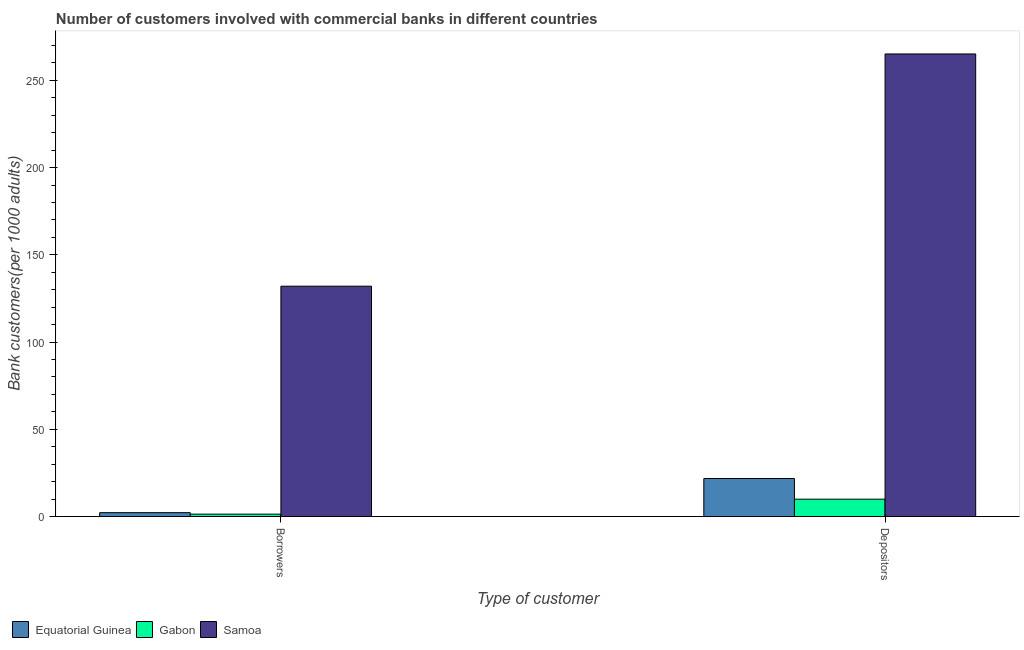How many different coloured bars are there?
Your answer should be very brief. 3. How many groups of bars are there?
Provide a short and direct response. 2. Are the number of bars per tick equal to the number of legend labels?
Your answer should be compact. Yes. Are the number of bars on each tick of the X-axis equal?
Your answer should be compact. Yes. How many bars are there on the 1st tick from the left?
Your answer should be compact. 3. What is the label of the 1st group of bars from the left?
Your answer should be compact. Borrowers. What is the number of borrowers in Samoa?
Give a very brief answer. 132.03. Across all countries, what is the maximum number of borrowers?
Offer a very short reply. 132.03. Across all countries, what is the minimum number of borrowers?
Make the answer very short. 1.38. In which country was the number of depositors maximum?
Ensure brevity in your answer.  Samoa. In which country was the number of depositors minimum?
Your answer should be very brief. Gabon. What is the total number of depositors in the graph?
Provide a short and direct response. 296.91. What is the difference between the number of depositors in Samoa and that in Equatorial Guinea?
Offer a terse response. 243.35. What is the difference between the number of borrowers in Equatorial Guinea and the number of depositors in Samoa?
Your response must be concise. -262.93. What is the average number of borrowers per country?
Provide a short and direct response. 45.21. What is the difference between the number of depositors and number of borrowers in Gabon?
Keep it short and to the point. 8.58. In how many countries, is the number of depositors greater than 40 ?
Provide a short and direct response. 1. What is the ratio of the number of borrowers in Samoa to that in Gabon?
Ensure brevity in your answer.  95.39. Is the number of borrowers in Equatorial Guinea less than that in Samoa?
Your response must be concise. Yes. What does the 1st bar from the left in Borrowers represents?
Make the answer very short. Equatorial Guinea. What does the 2nd bar from the right in Depositors represents?
Your response must be concise. Gabon. Where does the legend appear in the graph?
Keep it short and to the point. Bottom left. How are the legend labels stacked?
Provide a short and direct response. Horizontal. What is the title of the graph?
Your answer should be compact. Number of customers involved with commercial banks in different countries. What is the label or title of the X-axis?
Provide a short and direct response. Type of customer. What is the label or title of the Y-axis?
Offer a very short reply. Bank customers(per 1000 adults). What is the Bank customers(per 1000 adults) of Equatorial Guinea in Borrowers?
Ensure brevity in your answer.  2.22. What is the Bank customers(per 1000 adults) in Gabon in Borrowers?
Give a very brief answer. 1.38. What is the Bank customers(per 1000 adults) in Samoa in Borrowers?
Your response must be concise. 132.03. What is the Bank customers(per 1000 adults) in Equatorial Guinea in Depositors?
Keep it short and to the point. 21.8. What is the Bank customers(per 1000 adults) in Gabon in Depositors?
Ensure brevity in your answer.  9.96. What is the Bank customers(per 1000 adults) of Samoa in Depositors?
Give a very brief answer. 265.15. Across all Type of customer, what is the maximum Bank customers(per 1000 adults) of Equatorial Guinea?
Your answer should be very brief. 21.8. Across all Type of customer, what is the maximum Bank customers(per 1000 adults) in Gabon?
Make the answer very short. 9.96. Across all Type of customer, what is the maximum Bank customers(per 1000 adults) in Samoa?
Your answer should be compact. 265.15. Across all Type of customer, what is the minimum Bank customers(per 1000 adults) in Equatorial Guinea?
Provide a succinct answer. 2.22. Across all Type of customer, what is the minimum Bank customers(per 1000 adults) in Gabon?
Offer a very short reply. 1.38. Across all Type of customer, what is the minimum Bank customers(per 1000 adults) in Samoa?
Ensure brevity in your answer.  132.03. What is the total Bank customers(per 1000 adults) in Equatorial Guinea in the graph?
Make the answer very short. 24.02. What is the total Bank customers(per 1000 adults) of Gabon in the graph?
Your answer should be compact. 11.34. What is the total Bank customers(per 1000 adults) of Samoa in the graph?
Your answer should be compact. 397.18. What is the difference between the Bank customers(per 1000 adults) of Equatorial Guinea in Borrowers and that in Depositors?
Offer a very short reply. -19.58. What is the difference between the Bank customers(per 1000 adults) in Gabon in Borrowers and that in Depositors?
Your answer should be very brief. -8.57. What is the difference between the Bank customers(per 1000 adults) of Samoa in Borrowers and that in Depositors?
Make the answer very short. -133.12. What is the difference between the Bank customers(per 1000 adults) of Equatorial Guinea in Borrowers and the Bank customers(per 1000 adults) of Gabon in Depositors?
Ensure brevity in your answer.  -7.74. What is the difference between the Bank customers(per 1000 adults) of Equatorial Guinea in Borrowers and the Bank customers(per 1000 adults) of Samoa in Depositors?
Give a very brief answer. -262.93. What is the difference between the Bank customers(per 1000 adults) in Gabon in Borrowers and the Bank customers(per 1000 adults) in Samoa in Depositors?
Keep it short and to the point. -263.77. What is the average Bank customers(per 1000 adults) in Equatorial Guinea per Type of customer?
Offer a very short reply. 12.01. What is the average Bank customers(per 1000 adults) in Gabon per Type of customer?
Your answer should be compact. 5.67. What is the average Bank customers(per 1000 adults) in Samoa per Type of customer?
Your response must be concise. 198.59. What is the difference between the Bank customers(per 1000 adults) of Equatorial Guinea and Bank customers(per 1000 adults) of Gabon in Borrowers?
Your response must be concise. 0.84. What is the difference between the Bank customers(per 1000 adults) in Equatorial Guinea and Bank customers(per 1000 adults) in Samoa in Borrowers?
Give a very brief answer. -129.81. What is the difference between the Bank customers(per 1000 adults) of Gabon and Bank customers(per 1000 adults) of Samoa in Borrowers?
Make the answer very short. -130.64. What is the difference between the Bank customers(per 1000 adults) in Equatorial Guinea and Bank customers(per 1000 adults) in Gabon in Depositors?
Make the answer very short. 11.84. What is the difference between the Bank customers(per 1000 adults) of Equatorial Guinea and Bank customers(per 1000 adults) of Samoa in Depositors?
Your response must be concise. -243.35. What is the difference between the Bank customers(per 1000 adults) of Gabon and Bank customers(per 1000 adults) of Samoa in Depositors?
Keep it short and to the point. -255.19. What is the ratio of the Bank customers(per 1000 adults) of Equatorial Guinea in Borrowers to that in Depositors?
Your answer should be very brief. 0.1. What is the ratio of the Bank customers(per 1000 adults) of Gabon in Borrowers to that in Depositors?
Provide a succinct answer. 0.14. What is the ratio of the Bank customers(per 1000 adults) of Samoa in Borrowers to that in Depositors?
Keep it short and to the point. 0.5. What is the difference between the highest and the second highest Bank customers(per 1000 adults) in Equatorial Guinea?
Your answer should be very brief. 19.58. What is the difference between the highest and the second highest Bank customers(per 1000 adults) of Gabon?
Offer a very short reply. 8.57. What is the difference between the highest and the second highest Bank customers(per 1000 adults) of Samoa?
Provide a succinct answer. 133.12. What is the difference between the highest and the lowest Bank customers(per 1000 adults) of Equatorial Guinea?
Your answer should be compact. 19.58. What is the difference between the highest and the lowest Bank customers(per 1000 adults) of Gabon?
Your response must be concise. 8.57. What is the difference between the highest and the lowest Bank customers(per 1000 adults) of Samoa?
Give a very brief answer. 133.12. 